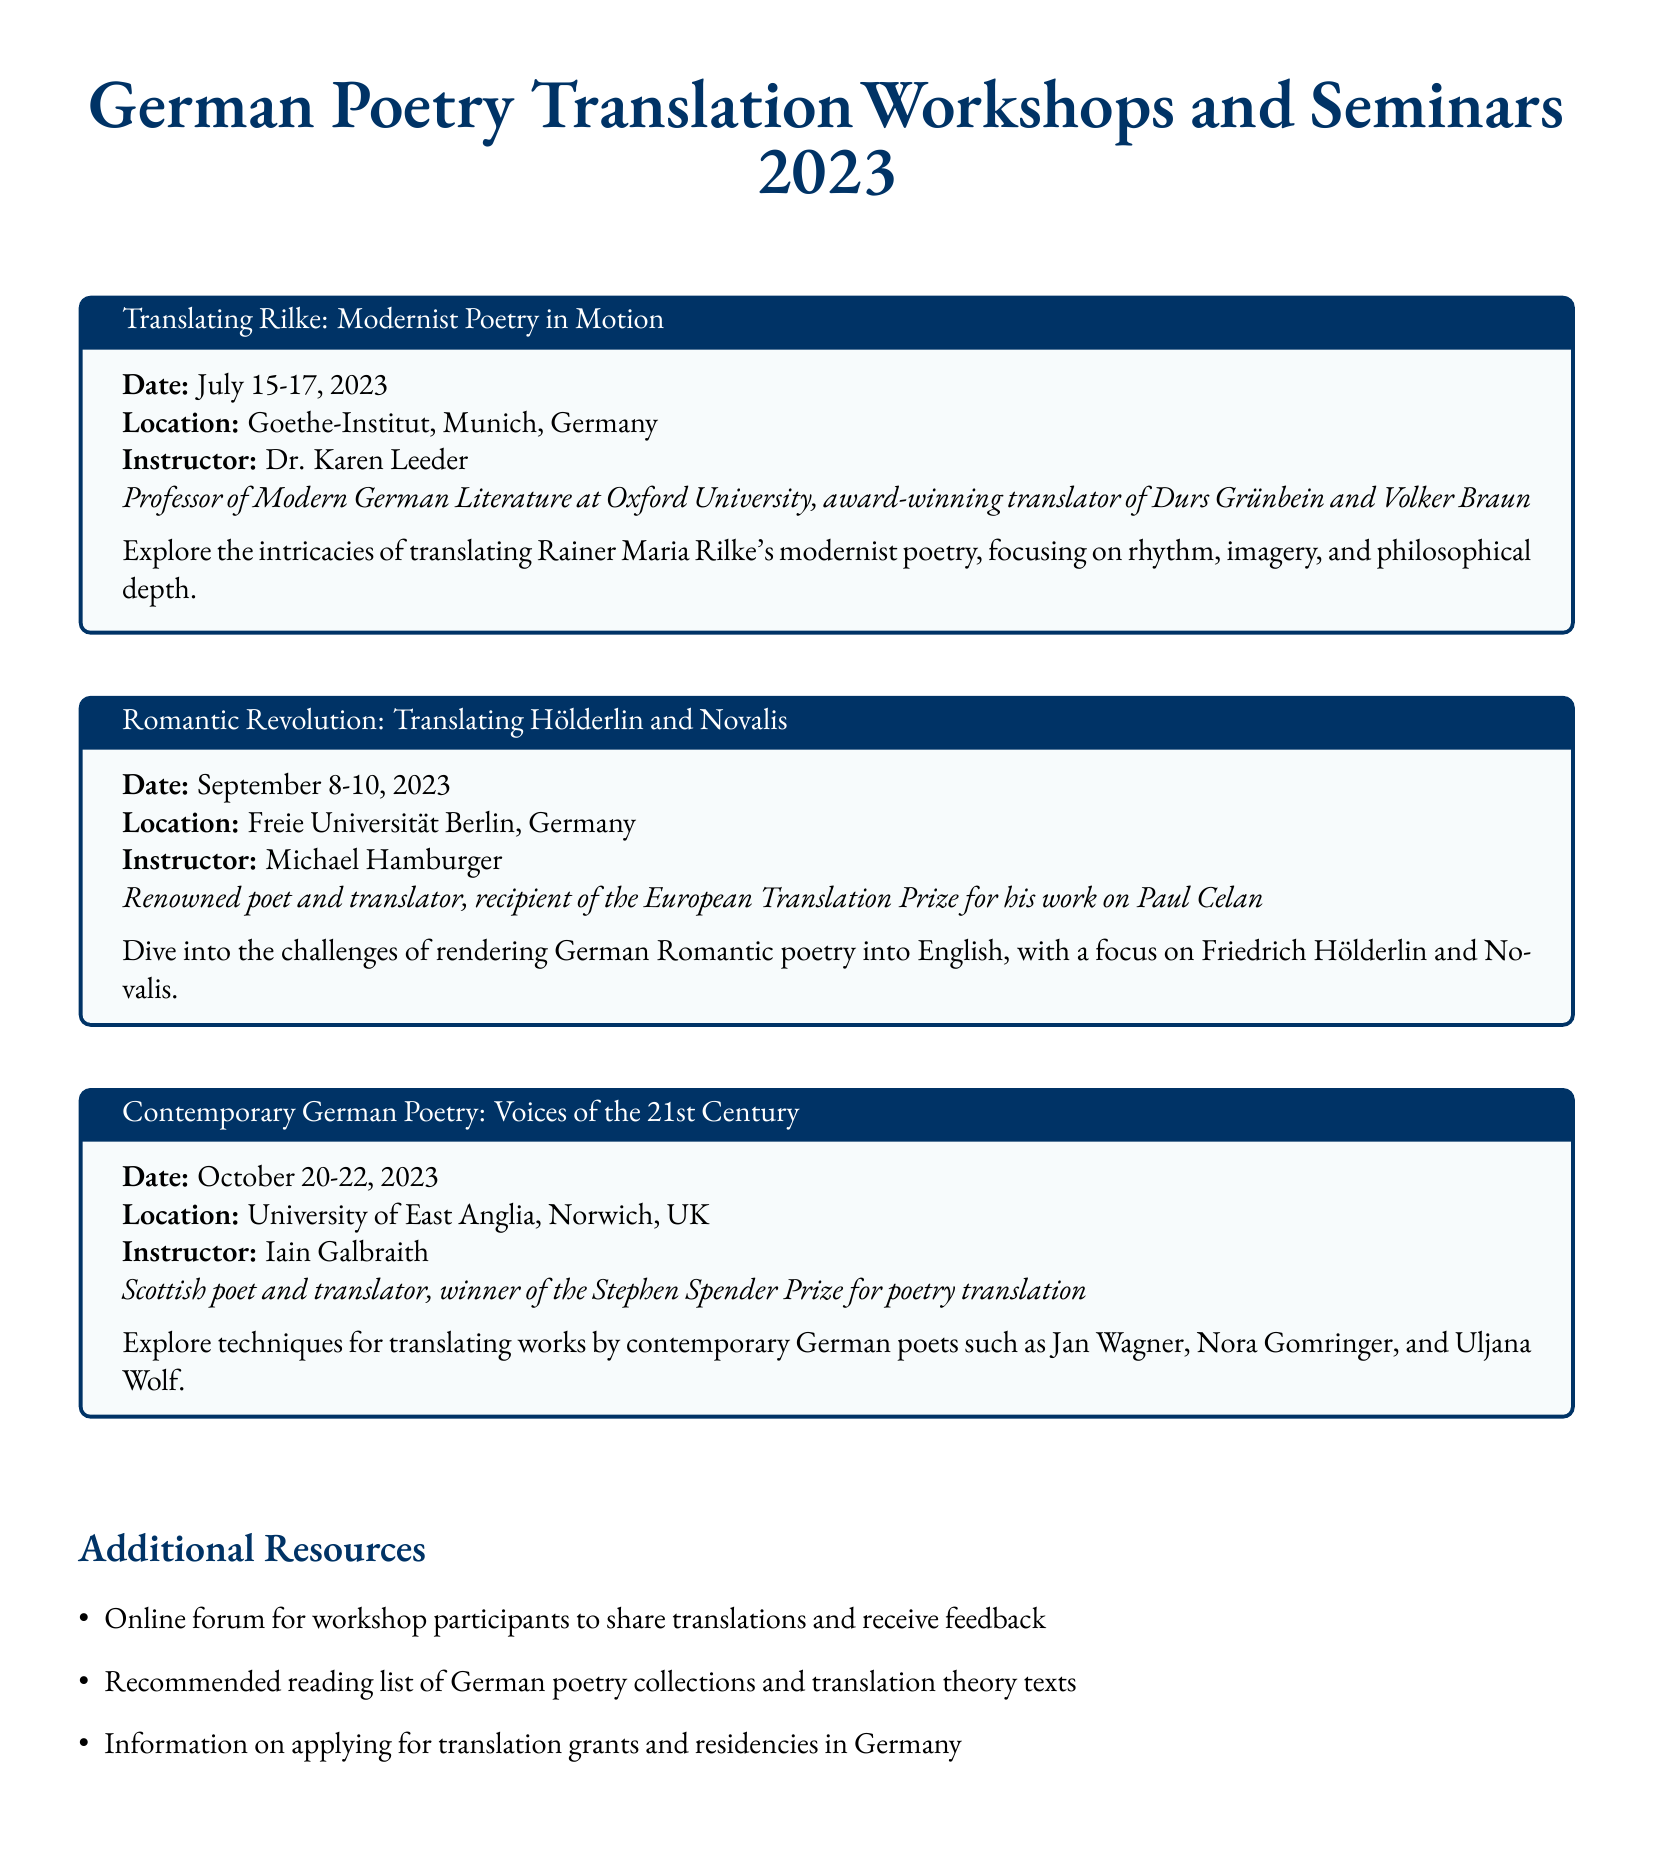What is the date of the workshop on translating Rilke? The date for the Rilke workshop is listed in the document.
Answer: July 15-17, 2023 Who is the instructor for the workshop on Hölderlin and Novalis? The instructor's name is mentioned in the seminar section for Hölderlin and Novalis.
Answer: Michael Hamburger Where is the Contemporary German Poetry workshop taking place? The location for the Contemporary German Poetry workshop is specified in the document.
Answer: University of East Anglia, Norwich, UK What award did Iain Galbraith win? The document states an award related to Iain Galbraith's translation achievements.
Answer: Stephen Spender Prize How many workshops are mentioned in the document? The total number of workshops can be counted from the listed seminars.
Answer: Three What is the focus of the workshop led by Dr. Karen Leeder? This refers to the theme or subject matter of the workshop as described in the title.
Answer: Translating Rilke What type of additional resource is mentioned for workshop participants? The document lists types of resources available to participants.
Answer: Online forum Which university is Dr. Karen Leeder associated with? The document provides information about Dr. Karen Leeder's affiliation.
Answer: Oxford University What is the setting for the workshop on Romantic Revolution? The document specifies the venue for the Romantic Revolution workshop.
Answer: Freie Universität Berlin, Germany 